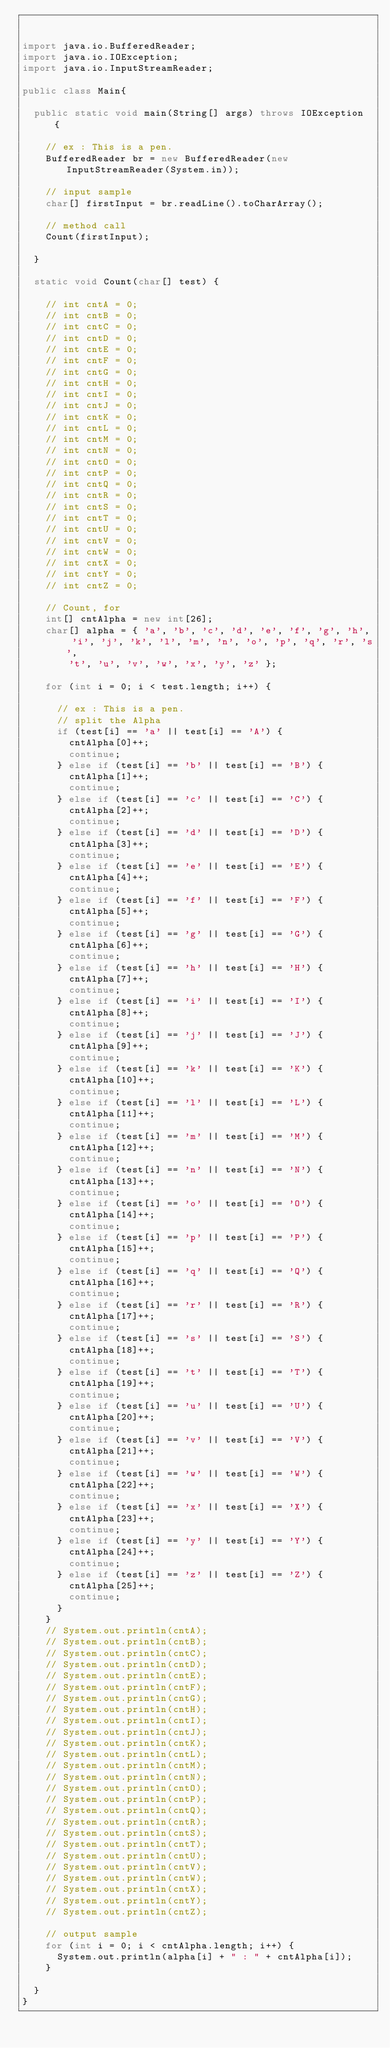Convert code to text. <code><loc_0><loc_0><loc_500><loc_500><_Java_>

import java.io.BufferedReader;
import java.io.IOException;
import java.io.InputStreamReader;

public class Main{

	public static void main(String[] args) throws IOException {

		// ex : This is a pen.
		BufferedReader br = new BufferedReader(new InputStreamReader(System.in));

		// input sample
		char[] firstInput = br.readLine().toCharArray();

		// method call
		Count(firstInput);

	}

	static void Count(char[] test) {

		// int cntA = 0;
		// int cntB = 0;
		// int cntC = 0;
		// int cntD = 0;
		// int cntE = 0;
		// int cntF = 0;
		// int cntG = 0;
		// int cntH = 0;
		// int cntI = 0;
		// int cntJ = 0;
		// int cntK = 0;
		// int cntL = 0;
		// int cntM = 0;
		// int cntN = 0;
		// int cntO = 0;
		// int cntP = 0;
		// int cntQ = 0;
		// int cntR = 0;
		// int cntS = 0;
		// int cntT = 0;
		// int cntU = 0;
		// int cntV = 0;
		// int cntW = 0;
		// int cntX = 0;
		// int cntY = 0;
		// int cntZ = 0;

		// Count, for
		int[] cntAlpha = new int[26];
		char[] alpha = { 'a', 'b', 'c', 'd', 'e', 'f', 'g', 'h', 'i', 'j', 'k', 'l', 'm', 'n', 'o', 'p', 'q', 'r', 's',
				't', 'u', 'v', 'w', 'x', 'y', 'z' };

		for (int i = 0; i < test.length; i++) {

			// ex : This is a pen.
			// split the Alpha
			if (test[i] == 'a' || test[i] == 'A') {
				cntAlpha[0]++;
				continue;
			} else if (test[i] == 'b' || test[i] == 'B') {
				cntAlpha[1]++;
				continue;
			} else if (test[i] == 'c' || test[i] == 'C') {
				cntAlpha[2]++;
				continue;
			} else if (test[i] == 'd' || test[i] == 'D') {
				cntAlpha[3]++;
				continue;
			} else if (test[i] == 'e' || test[i] == 'E') {
				cntAlpha[4]++;
				continue;
			} else if (test[i] == 'f' || test[i] == 'F') {
				cntAlpha[5]++;
				continue;
			} else if (test[i] == 'g' || test[i] == 'G') {
				cntAlpha[6]++;
				continue;
			} else if (test[i] == 'h' || test[i] == 'H') {
				cntAlpha[7]++;
				continue;
			} else if (test[i] == 'i' || test[i] == 'I') {
				cntAlpha[8]++;
				continue;
			} else if (test[i] == 'j' || test[i] == 'J') {
				cntAlpha[9]++;
				continue;
			} else if (test[i] == 'k' || test[i] == 'K') {
				cntAlpha[10]++;
				continue;
			} else if (test[i] == 'l' || test[i] == 'L') {
				cntAlpha[11]++;
				continue;
			} else if (test[i] == 'm' || test[i] == 'M') {
				cntAlpha[12]++;
				continue;
			} else if (test[i] == 'n' || test[i] == 'N') {
				cntAlpha[13]++;
				continue;
			} else if (test[i] == 'o' || test[i] == 'O') {
				cntAlpha[14]++;
				continue;
			} else if (test[i] == 'p' || test[i] == 'P') {
				cntAlpha[15]++;
				continue;
			} else if (test[i] == 'q' || test[i] == 'Q') {
				cntAlpha[16]++;
				continue;
			} else if (test[i] == 'r' || test[i] == 'R') {
				cntAlpha[17]++;
				continue;
			} else if (test[i] == 's' || test[i] == 'S') {
				cntAlpha[18]++;
				continue;
			} else if (test[i] == 't' || test[i] == 'T') {
				cntAlpha[19]++;
				continue;
			} else if (test[i] == 'u' || test[i] == 'U') {
				cntAlpha[20]++;
				continue;
			} else if (test[i] == 'v' || test[i] == 'V') {
				cntAlpha[21]++;
				continue;
			} else if (test[i] == 'w' || test[i] == 'W') {
				cntAlpha[22]++;
				continue;
			} else if (test[i] == 'x' || test[i] == 'X') {
				cntAlpha[23]++;
				continue;
			} else if (test[i] == 'y' || test[i] == 'Y') {
				cntAlpha[24]++;
				continue;
			} else if (test[i] == 'z' || test[i] == 'Z') {
				cntAlpha[25]++;
				continue;
			}
		}
		// System.out.println(cntA);
		// System.out.println(cntB);
		// System.out.println(cntC);
		// System.out.println(cntD);
		// System.out.println(cntE);
		// System.out.println(cntF);
		// System.out.println(cntG);
		// System.out.println(cntH);
		// System.out.println(cntI);
		// System.out.println(cntJ);
		// System.out.println(cntK);
		// System.out.println(cntL);
		// System.out.println(cntM);
		// System.out.println(cntN);
		// System.out.println(cntO);
		// System.out.println(cntP);
		// System.out.println(cntQ);
		// System.out.println(cntR);
		// System.out.println(cntS);
		// System.out.println(cntT);
		// System.out.println(cntU);
		// System.out.println(cntV);
		// System.out.println(cntW);
		// System.out.println(cntX);
		// System.out.println(cntY);
		// System.out.println(cntZ);

		// output sample
		for (int i = 0; i < cntAlpha.length; i++) {
			System.out.println(alpha[i] + " : " + cntAlpha[i]);
		}

	}
}</code> 